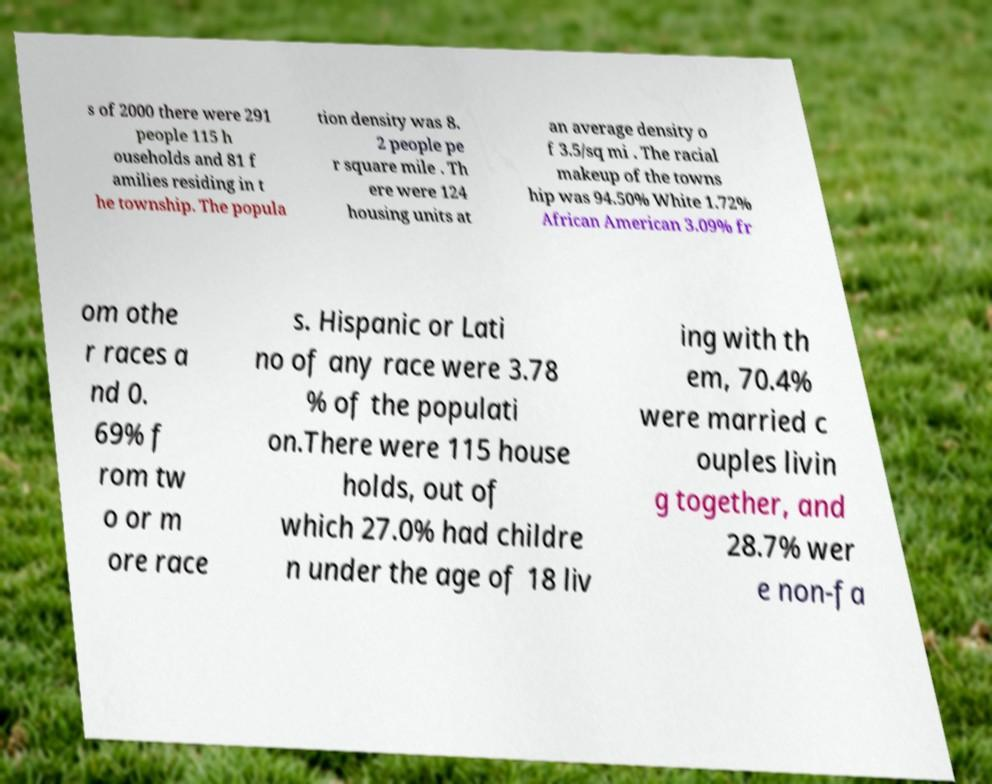I need the written content from this picture converted into text. Can you do that? s of 2000 there were 291 people 115 h ouseholds and 81 f amilies residing in t he township. The popula tion density was 8. 2 people pe r square mile . Th ere were 124 housing units at an average density o f 3.5/sq mi . The racial makeup of the towns hip was 94.50% White 1.72% African American 3.09% fr om othe r races a nd 0. 69% f rom tw o or m ore race s. Hispanic or Lati no of any race were 3.78 % of the populati on.There were 115 house holds, out of which 27.0% had childre n under the age of 18 liv ing with th em, 70.4% were married c ouples livin g together, and 28.7% wer e non-fa 